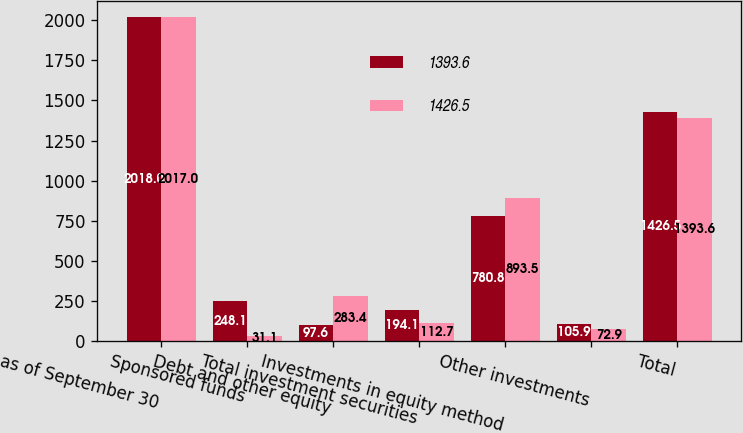<chart> <loc_0><loc_0><loc_500><loc_500><stacked_bar_chart><ecel><fcel>as of September 30<fcel>Sponsored funds<fcel>Debt and other equity<fcel>Total investment securities<fcel>Investments in equity method<fcel>Other investments<fcel>Total<nl><fcel>1393.6<fcel>2018<fcel>248.1<fcel>97.6<fcel>194.1<fcel>780.8<fcel>105.9<fcel>1426.5<nl><fcel>1426.5<fcel>2017<fcel>31.1<fcel>283.4<fcel>112.7<fcel>893.5<fcel>72.9<fcel>1393.6<nl></chart> 